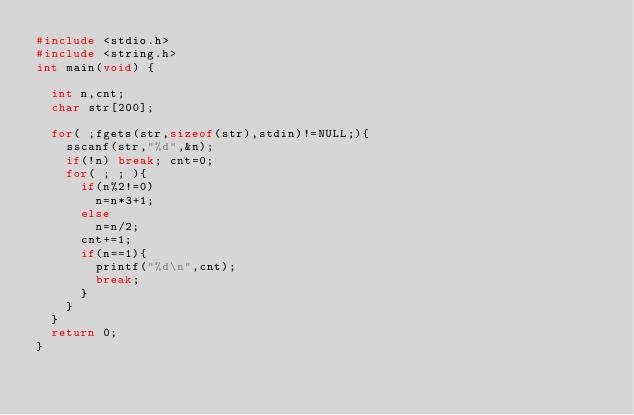<code> <loc_0><loc_0><loc_500><loc_500><_C_>#include <stdio.h>
#include <string.h>
int main(void) {

	int n,cnt;
	char str[200];

	for( ;fgets(str,sizeof(str),stdin)!=NULL;){
		sscanf(str,"%d",&n);
		if(!n) break; cnt=0;
		for( ; ; ){
			if(n%2!=0)
				n=n*3+1;
			else
				n=n/2;
			cnt+=1;
			if(n==1){
				printf("%d\n",cnt);
				break;
			}
		}
	}	
	return 0;
}</code> 